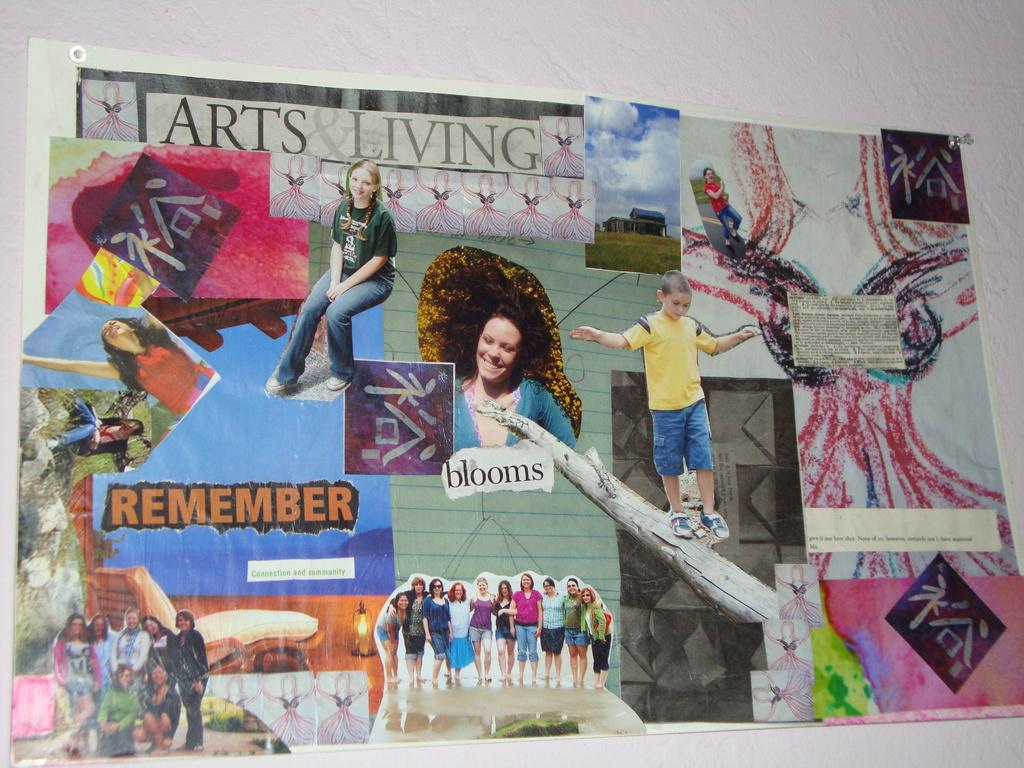<image>
Provide a brief description of the given image. A poster with people on it with labels like Arts Living and Remember and Blooms. 